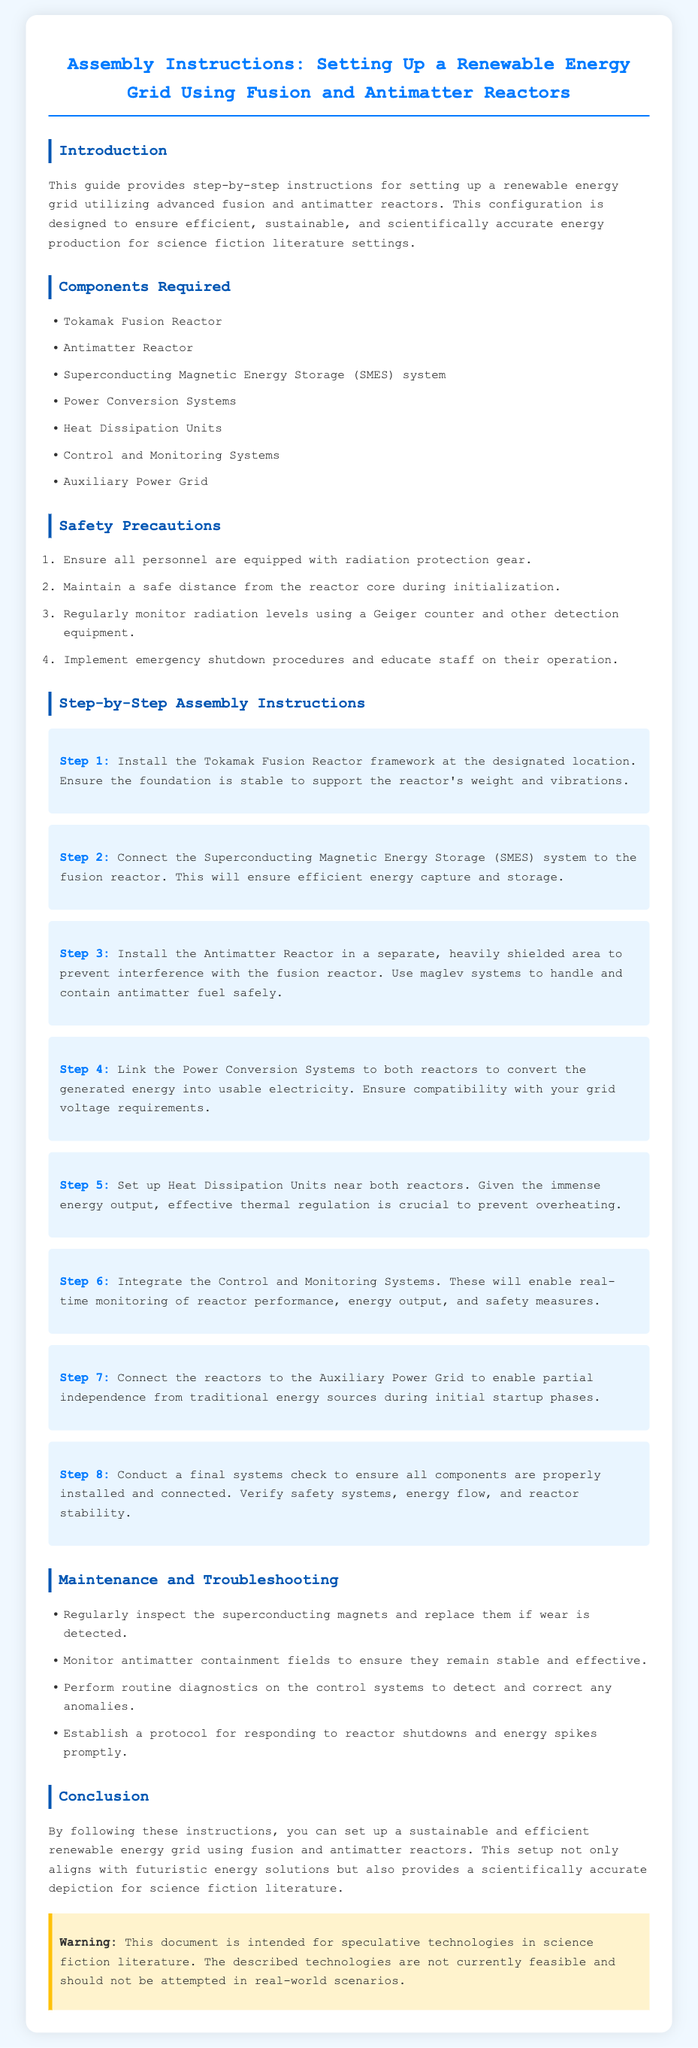What are the first two components required? The first two components listed in the document are the Tokamak Fusion Reactor and the Antimatter Reactor.
Answer: Tokamak Fusion Reactor, Antimatter Reactor What is the safety precaution related to personnel? The document states that all personnel must be equipped with radiation protection gear.
Answer: Radiation protection gear How many steps are in the assembly instructions? There are eight distinct steps outlined in the assembly instructions.
Answer: 8 What type of energy storage system should be connected to the fusion reactor? The document specifies that a Superconducting Magnetic Energy Storage (SMES) system should be connected to the fusion reactor.
Answer: Superconducting Magnetic Energy Storage (SMES) What should be monitored to ensure stability in the antimatter reactor? The document indicates that antimatter containment fields should be monitored for stability.
Answer: Containment fields What is recommended for the reactor cores during initialization? Personnel should maintain a safe distance from the reactor core during initialization.
Answer: Safe distance Which system is important for conducting routine diagnostics? The Control and Monitoring Systems are important for performing routine diagnostics.
Answer: Control and Monitoring Systems What is the final step in the assembly instructions? The final step detailed in the assembly instructions is to conduct a final systems check.
Answer: Final systems check 